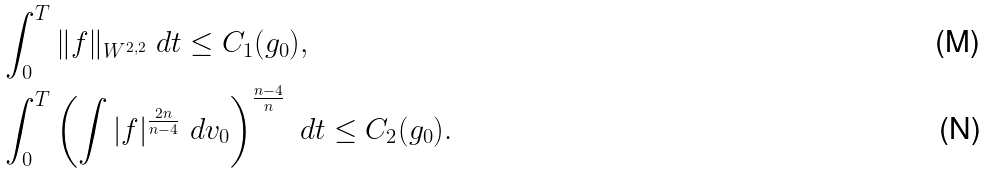Convert formula to latex. <formula><loc_0><loc_0><loc_500><loc_500>& \int _ { 0 } ^ { T } \| f \| _ { W ^ { 2 , 2 } } \ d t \leq C _ { 1 } ( g _ { 0 } ) , \\ & \int _ { 0 } ^ { T } \left ( \int | f | ^ { \frac { 2 n } { n - 4 } } \ d v _ { 0 } \right ) ^ { \frac { n - 4 } { n } } \ d t \leq C _ { 2 } ( g _ { 0 } ) .</formula> 